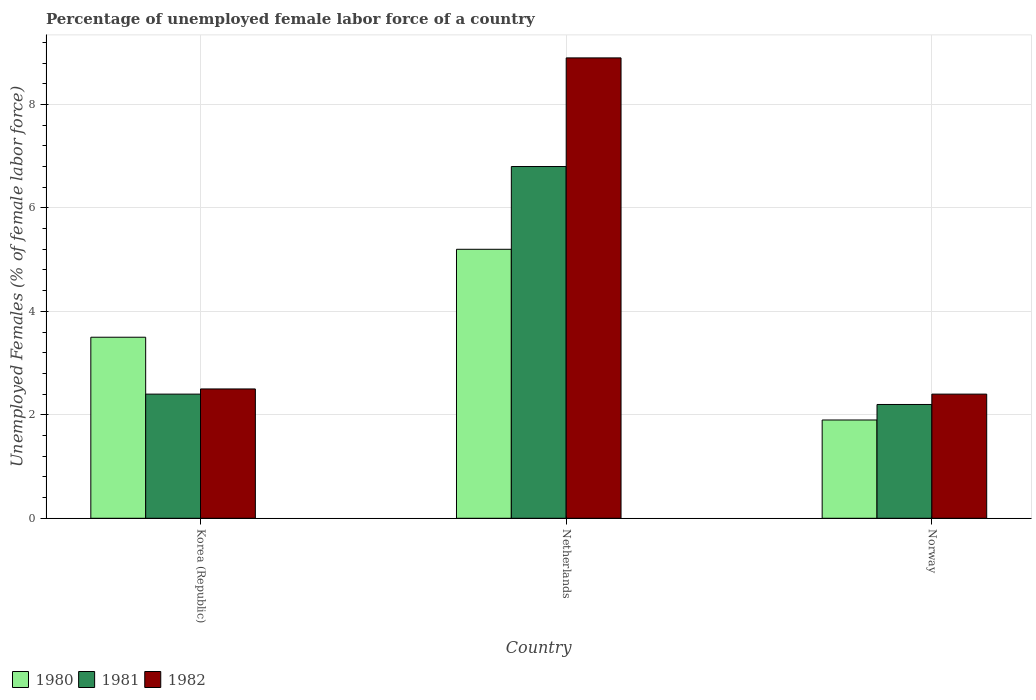How many groups of bars are there?
Make the answer very short. 3. Are the number of bars per tick equal to the number of legend labels?
Your answer should be compact. Yes. Are the number of bars on each tick of the X-axis equal?
Provide a short and direct response. Yes. How many bars are there on the 1st tick from the right?
Keep it short and to the point. 3. In how many cases, is the number of bars for a given country not equal to the number of legend labels?
Your answer should be very brief. 0. Across all countries, what is the maximum percentage of unemployed female labor force in 1980?
Your response must be concise. 5.2. Across all countries, what is the minimum percentage of unemployed female labor force in 1981?
Give a very brief answer. 2.2. In which country was the percentage of unemployed female labor force in 1982 minimum?
Your answer should be compact. Norway. What is the total percentage of unemployed female labor force in 1981 in the graph?
Offer a terse response. 11.4. What is the difference between the percentage of unemployed female labor force in 1982 in Netherlands and that in Norway?
Provide a succinct answer. 6.5. What is the difference between the percentage of unemployed female labor force in 1981 in Netherlands and the percentage of unemployed female labor force in 1980 in Korea (Republic)?
Offer a terse response. 3.3. What is the average percentage of unemployed female labor force in 1982 per country?
Give a very brief answer. 4.6. What is the difference between the percentage of unemployed female labor force of/in 1981 and percentage of unemployed female labor force of/in 1982 in Korea (Republic)?
Offer a very short reply. -0.1. In how many countries, is the percentage of unemployed female labor force in 1981 greater than 6.4 %?
Give a very brief answer. 1. What is the ratio of the percentage of unemployed female labor force in 1981 in Korea (Republic) to that in Norway?
Offer a very short reply. 1.09. Is the difference between the percentage of unemployed female labor force in 1981 in Korea (Republic) and Netherlands greater than the difference between the percentage of unemployed female labor force in 1982 in Korea (Republic) and Netherlands?
Make the answer very short. Yes. What is the difference between the highest and the second highest percentage of unemployed female labor force in 1982?
Give a very brief answer. 6.4. What is the difference between the highest and the lowest percentage of unemployed female labor force in 1982?
Offer a very short reply. 6.5. What does the 1st bar from the left in Norway represents?
Offer a terse response. 1980. Are all the bars in the graph horizontal?
Your answer should be compact. No. How many countries are there in the graph?
Offer a very short reply. 3. Does the graph contain any zero values?
Your response must be concise. No. Where does the legend appear in the graph?
Offer a terse response. Bottom left. How are the legend labels stacked?
Make the answer very short. Horizontal. What is the title of the graph?
Make the answer very short. Percentage of unemployed female labor force of a country. Does "1980" appear as one of the legend labels in the graph?
Offer a terse response. Yes. What is the label or title of the X-axis?
Ensure brevity in your answer.  Country. What is the label or title of the Y-axis?
Provide a succinct answer. Unemployed Females (% of female labor force). What is the Unemployed Females (% of female labor force) in 1981 in Korea (Republic)?
Your response must be concise. 2.4. What is the Unemployed Females (% of female labor force) of 1980 in Netherlands?
Your answer should be compact. 5.2. What is the Unemployed Females (% of female labor force) in 1981 in Netherlands?
Your response must be concise. 6.8. What is the Unemployed Females (% of female labor force) in 1982 in Netherlands?
Keep it short and to the point. 8.9. What is the Unemployed Females (% of female labor force) in 1980 in Norway?
Give a very brief answer. 1.9. What is the Unemployed Females (% of female labor force) of 1981 in Norway?
Offer a terse response. 2.2. What is the Unemployed Females (% of female labor force) of 1982 in Norway?
Your answer should be compact. 2.4. Across all countries, what is the maximum Unemployed Females (% of female labor force) of 1980?
Provide a succinct answer. 5.2. Across all countries, what is the maximum Unemployed Females (% of female labor force) in 1981?
Give a very brief answer. 6.8. Across all countries, what is the maximum Unemployed Females (% of female labor force) of 1982?
Give a very brief answer. 8.9. Across all countries, what is the minimum Unemployed Females (% of female labor force) of 1980?
Make the answer very short. 1.9. Across all countries, what is the minimum Unemployed Females (% of female labor force) in 1981?
Offer a very short reply. 2.2. Across all countries, what is the minimum Unemployed Females (% of female labor force) of 1982?
Offer a terse response. 2.4. What is the total Unemployed Females (% of female labor force) in 1980 in the graph?
Your answer should be compact. 10.6. What is the total Unemployed Females (% of female labor force) of 1982 in the graph?
Keep it short and to the point. 13.8. What is the difference between the Unemployed Females (% of female labor force) in 1980 in Korea (Republic) and that in Netherlands?
Ensure brevity in your answer.  -1.7. What is the difference between the Unemployed Females (% of female labor force) of 1981 in Korea (Republic) and that in Netherlands?
Give a very brief answer. -4.4. What is the difference between the Unemployed Females (% of female labor force) in 1980 in Korea (Republic) and that in Norway?
Ensure brevity in your answer.  1.6. What is the difference between the Unemployed Females (% of female labor force) in 1981 in Korea (Republic) and that in Norway?
Ensure brevity in your answer.  0.2. What is the difference between the Unemployed Females (% of female labor force) in 1981 in Netherlands and that in Norway?
Your answer should be very brief. 4.6. What is the difference between the Unemployed Females (% of female labor force) in 1980 in Korea (Republic) and the Unemployed Females (% of female labor force) in 1982 in Netherlands?
Ensure brevity in your answer.  -5.4. What is the difference between the Unemployed Females (% of female labor force) in 1980 in Korea (Republic) and the Unemployed Females (% of female labor force) in 1982 in Norway?
Provide a succinct answer. 1.1. What is the difference between the Unemployed Females (% of female labor force) in 1980 in Netherlands and the Unemployed Females (% of female labor force) in 1981 in Norway?
Keep it short and to the point. 3. What is the difference between the Unemployed Females (% of female labor force) of 1980 in Netherlands and the Unemployed Females (% of female labor force) of 1982 in Norway?
Offer a terse response. 2.8. What is the average Unemployed Females (% of female labor force) in 1980 per country?
Give a very brief answer. 3.53. What is the average Unemployed Females (% of female labor force) of 1982 per country?
Give a very brief answer. 4.6. What is the difference between the Unemployed Females (% of female labor force) of 1980 and Unemployed Females (% of female labor force) of 1981 in Korea (Republic)?
Make the answer very short. 1.1. What is the difference between the Unemployed Females (% of female labor force) in 1981 and Unemployed Females (% of female labor force) in 1982 in Korea (Republic)?
Provide a short and direct response. -0.1. What is the difference between the Unemployed Females (% of female labor force) in 1980 and Unemployed Females (% of female labor force) in 1981 in Netherlands?
Your response must be concise. -1.6. What is the difference between the Unemployed Females (% of female labor force) of 1980 and Unemployed Females (% of female labor force) of 1982 in Netherlands?
Ensure brevity in your answer.  -3.7. What is the difference between the Unemployed Females (% of female labor force) in 1980 and Unemployed Females (% of female labor force) in 1982 in Norway?
Ensure brevity in your answer.  -0.5. What is the difference between the Unemployed Females (% of female labor force) of 1981 and Unemployed Females (% of female labor force) of 1982 in Norway?
Provide a succinct answer. -0.2. What is the ratio of the Unemployed Females (% of female labor force) of 1980 in Korea (Republic) to that in Netherlands?
Offer a terse response. 0.67. What is the ratio of the Unemployed Females (% of female labor force) of 1981 in Korea (Republic) to that in Netherlands?
Your answer should be compact. 0.35. What is the ratio of the Unemployed Females (% of female labor force) of 1982 in Korea (Republic) to that in Netherlands?
Your answer should be very brief. 0.28. What is the ratio of the Unemployed Females (% of female labor force) of 1980 in Korea (Republic) to that in Norway?
Offer a very short reply. 1.84. What is the ratio of the Unemployed Females (% of female labor force) in 1981 in Korea (Republic) to that in Norway?
Provide a succinct answer. 1.09. What is the ratio of the Unemployed Females (% of female labor force) in 1982 in Korea (Republic) to that in Norway?
Keep it short and to the point. 1.04. What is the ratio of the Unemployed Females (% of female labor force) of 1980 in Netherlands to that in Norway?
Your answer should be compact. 2.74. What is the ratio of the Unemployed Females (% of female labor force) of 1981 in Netherlands to that in Norway?
Your response must be concise. 3.09. What is the ratio of the Unemployed Females (% of female labor force) in 1982 in Netherlands to that in Norway?
Make the answer very short. 3.71. What is the difference between the highest and the second highest Unemployed Females (% of female labor force) of 1981?
Provide a succinct answer. 4.4. 